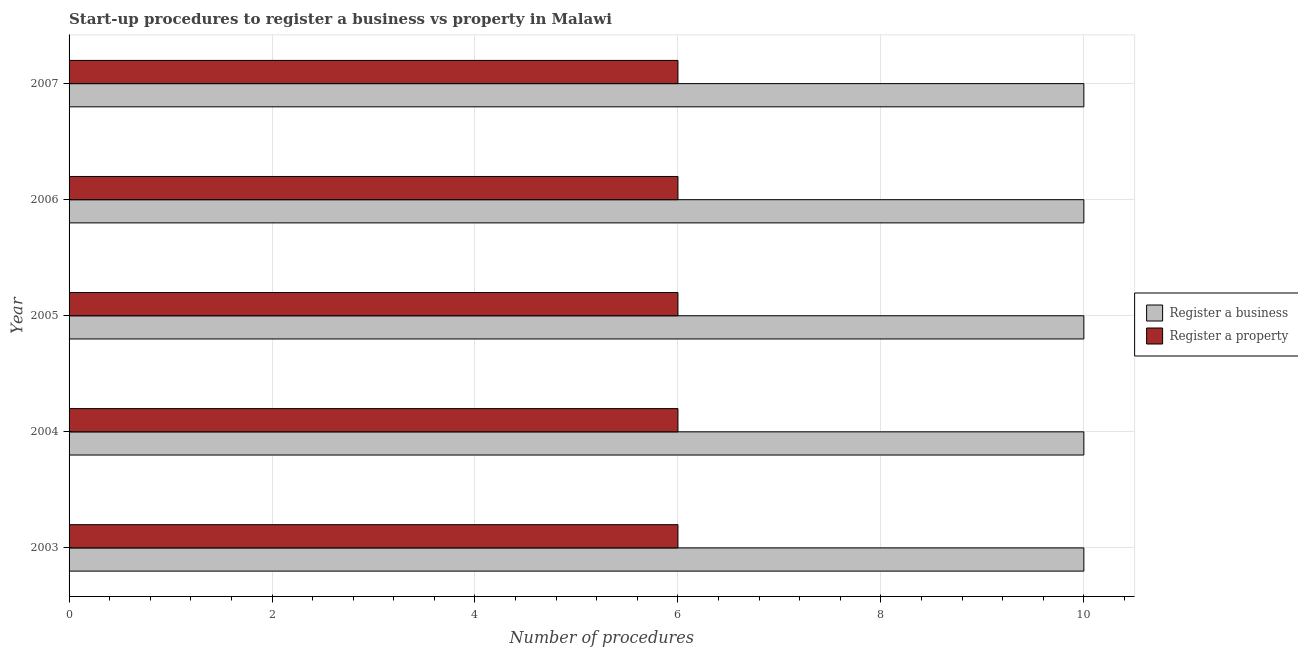How many different coloured bars are there?
Keep it short and to the point. 2. How many groups of bars are there?
Your response must be concise. 5. How many bars are there on the 1st tick from the top?
Ensure brevity in your answer.  2. How many bars are there on the 1st tick from the bottom?
Offer a very short reply. 2. In how many cases, is the number of bars for a given year not equal to the number of legend labels?
Provide a succinct answer. 0. What is the number of procedures to register a business in 2004?
Ensure brevity in your answer.  10. Across all years, what is the maximum number of procedures to register a business?
Your answer should be compact. 10. What is the total number of procedures to register a property in the graph?
Offer a very short reply. 30. What is the difference between the number of procedures to register a property in 2004 and that in 2005?
Your answer should be compact. 0. What is the difference between the number of procedures to register a business in 2003 and the number of procedures to register a property in 2007?
Offer a terse response. 4. In the year 2006, what is the difference between the number of procedures to register a business and number of procedures to register a property?
Make the answer very short. 4. Is the number of procedures to register a property in 2003 less than that in 2005?
Make the answer very short. No. What is the difference between the highest and the second highest number of procedures to register a property?
Keep it short and to the point. 0. What is the difference between the highest and the lowest number of procedures to register a property?
Provide a succinct answer. 0. In how many years, is the number of procedures to register a business greater than the average number of procedures to register a business taken over all years?
Give a very brief answer. 0. Is the sum of the number of procedures to register a property in 2004 and 2006 greater than the maximum number of procedures to register a business across all years?
Offer a terse response. Yes. What does the 1st bar from the top in 2006 represents?
Make the answer very short. Register a property. What does the 2nd bar from the bottom in 2003 represents?
Keep it short and to the point. Register a property. How many bars are there?
Your answer should be compact. 10. How many years are there in the graph?
Give a very brief answer. 5. How are the legend labels stacked?
Your response must be concise. Vertical. What is the title of the graph?
Provide a succinct answer. Start-up procedures to register a business vs property in Malawi. What is the label or title of the X-axis?
Give a very brief answer. Number of procedures. What is the Number of procedures of Register a property in 2003?
Provide a succinct answer. 6. What is the Number of procedures of Register a business in 2004?
Give a very brief answer. 10. What is the Number of procedures in Register a property in 2004?
Your answer should be very brief. 6. What is the Number of procedures of Register a property in 2005?
Ensure brevity in your answer.  6. What is the Number of procedures in Register a business in 2006?
Provide a succinct answer. 10. What is the Number of procedures of Register a property in 2006?
Provide a short and direct response. 6. What is the Number of procedures of Register a business in 2007?
Provide a succinct answer. 10. What is the Number of procedures in Register a property in 2007?
Give a very brief answer. 6. Across all years, what is the minimum Number of procedures in Register a business?
Offer a terse response. 10. Across all years, what is the minimum Number of procedures of Register a property?
Your response must be concise. 6. What is the total Number of procedures in Register a property in the graph?
Give a very brief answer. 30. What is the difference between the Number of procedures in Register a business in 2003 and that in 2005?
Provide a short and direct response. 0. What is the difference between the Number of procedures in Register a business in 2003 and that in 2006?
Keep it short and to the point. 0. What is the difference between the Number of procedures in Register a business in 2003 and that in 2007?
Give a very brief answer. 0. What is the difference between the Number of procedures in Register a business in 2004 and that in 2005?
Give a very brief answer. 0. What is the difference between the Number of procedures of Register a business in 2004 and that in 2006?
Offer a terse response. 0. What is the difference between the Number of procedures of Register a property in 2004 and that in 2006?
Your answer should be compact. 0. What is the difference between the Number of procedures of Register a business in 2006 and that in 2007?
Offer a terse response. 0. What is the difference between the Number of procedures in Register a business in 2003 and the Number of procedures in Register a property in 2004?
Your response must be concise. 4. What is the difference between the Number of procedures of Register a business in 2003 and the Number of procedures of Register a property in 2005?
Your response must be concise. 4. What is the difference between the Number of procedures in Register a business in 2003 and the Number of procedures in Register a property in 2007?
Make the answer very short. 4. What is the difference between the Number of procedures of Register a business in 2004 and the Number of procedures of Register a property in 2007?
Give a very brief answer. 4. What is the difference between the Number of procedures of Register a business in 2006 and the Number of procedures of Register a property in 2007?
Your answer should be very brief. 4. What is the average Number of procedures in Register a business per year?
Give a very brief answer. 10. In the year 2003, what is the difference between the Number of procedures in Register a business and Number of procedures in Register a property?
Your answer should be compact. 4. In the year 2005, what is the difference between the Number of procedures in Register a business and Number of procedures in Register a property?
Keep it short and to the point. 4. In the year 2006, what is the difference between the Number of procedures of Register a business and Number of procedures of Register a property?
Keep it short and to the point. 4. What is the ratio of the Number of procedures in Register a property in 2003 to that in 2004?
Offer a terse response. 1. What is the ratio of the Number of procedures in Register a business in 2003 to that in 2005?
Your answer should be compact. 1. What is the ratio of the Number of procedures of Register a business in 2003 to that in 2007?
Provide a succinct answer. 1. What is the ratio of the Number of procedures of Register a property in 2004 to that in 2005?
Your answer should be compact. 1. What is the ratio of the Number of procedures of Register a property in 2004 to that in 2006?
Offer a terse response. 1. What is the ratio of the Number of procedures in Register a property in 2005 to that in 2006?
Provide a succinct answer. 1. What is the ratio of the Number of procedures of Register a property in 2006 to that in 2007?
Give a very brief answer. 1. What is the difference between the highest and the second highest Number of procedures in Register a business?
Your answer should be very brief. 0. What is the difference between the highest and the second highest Number of procedures of Register a property?
Give a very brief answer. 0. What is the difference between the highest and the lowest Number of procedures of Register a property?
Offer a very short reply. 0. 